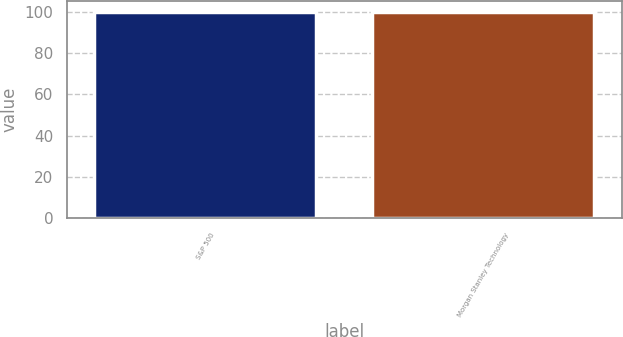Convert chart to OTSL. <chart><loc_0><loc_0><loc_500><loc_500><bar_chart><fcel>S&P 500<fcel>Morgan Stanley Technology<nl><fcel>100<fcel>100.1<nl></chart> 